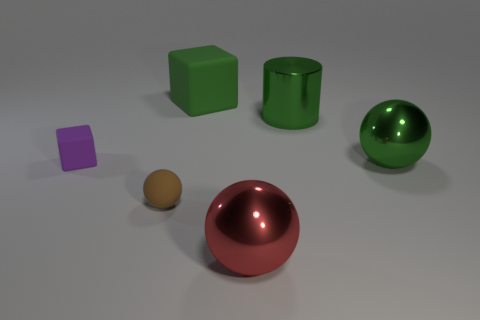Add 2 large green objects. How many objects exist? 8 Subtract all metallic spheres. How many spheres are left? 1 Subtract all green spheres. How many spheres are left? 2 Subtract all cylinders. How many objects are left? 5 Subtract all purple cubes. Subtract all red cylinders. How many cubes are left? 1 Subtract all yellow cylinders. How many blue spheres are left? 0 Subtract all yellow cylinders. Subtract all green rubber blocks. How many objects are left? 5 Add 3 tiny rubber objects. How many tiny rubber objects are left? 5 Add 1 big purple balls. How many big purple balls exist? 1 Subtract 0 purple spheres. How many objects are left? 6 